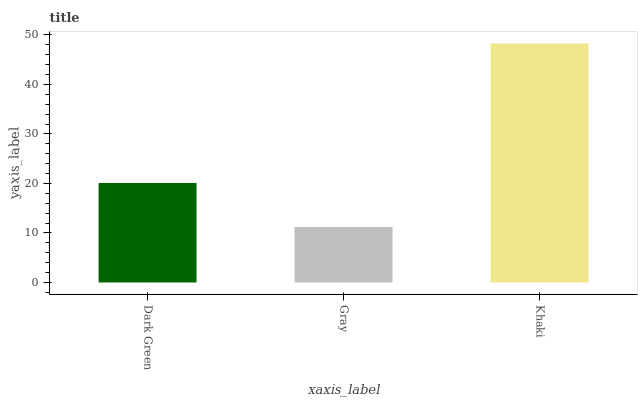Is Gray the minimum?
Answer yes or no. Yes. Is Khaki the maximum?
Answer yes or no. Yes. Is Khaki the minimum?
Answer yes or no. No. Is Gray the maximum?
Answer yes or no. No. Is Khaki greater than Gray?
Answer yes or no. Yes. Is Gray less than Khaki?
Answer yes or no. Yes. Is Gray greater than Khaki?
Answer yes or no. No. Is Khaki less than Gray?
Answer yes or no. No. Is Dark Green the high median?
Answer yes or no. Yes. Is Dark Green the low median?
Answer yes or no. Yes. Is Gray the high median?
Answer yes or no. No. Is Khaki the low median?
Answer yes or no. No. 